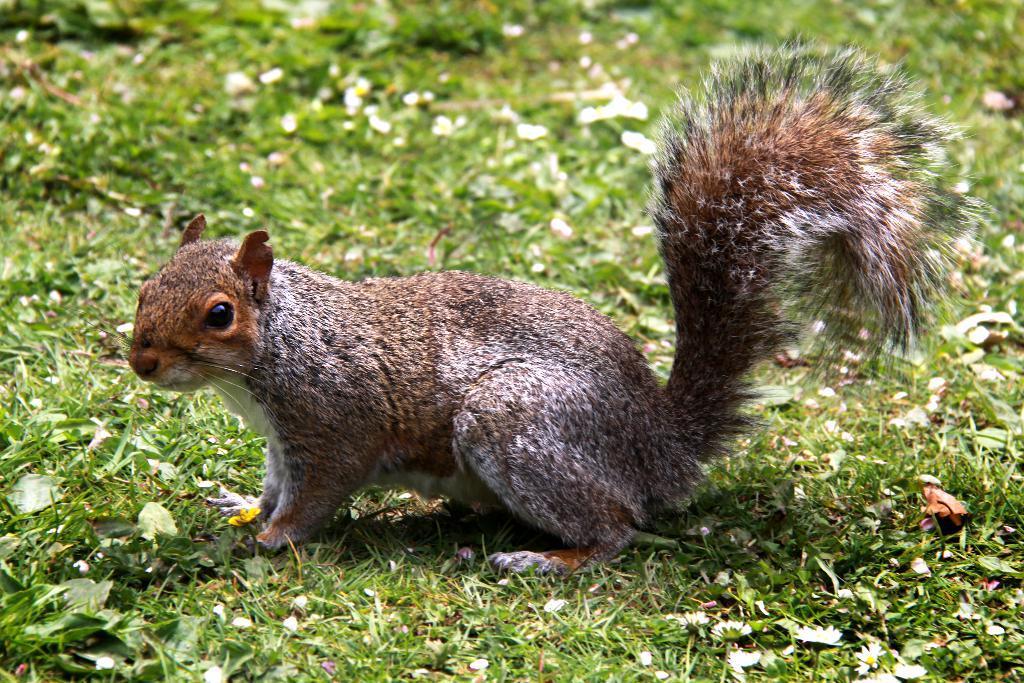In one or two sentences, can you explain what this image depicts? In the image there is a squirrel standing on a grassland. 